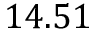Convert formula to latex. <formula><loc_0><loc_0><loc_500><loc_500>1 4 . 5 1</formula> 